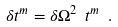Convert formula to latex. <formula><loc_0><loc_0><loc_500><loc_500>\delta t ^ { m } = \delta { \Omega ^ { 2 } } \ t ^ { m } \ .</formula> 